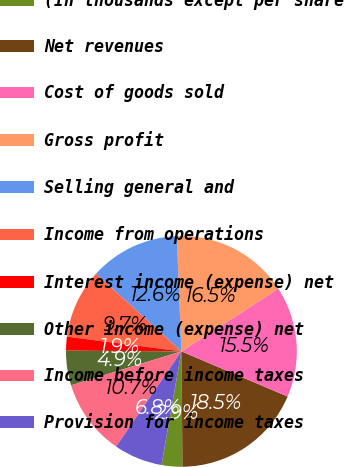Convert chart to OTSL. <chart><loc_0><loc_0><loc_500><loc_500><pie_chart><fcel>(In thousands except per share<fcel>Net revenues<fcel>Cost of goods sold<fcel>Gross profit<fcel>Selling general and<fcel>Income from operations<fcel>Interest income (expense) net<fcel>Other income (expense) net<fcel>Income before income taxes<fcel>Provision for income taxes<nl><fcel>2.91%<fcel>18.45%<fcel>15.53%<fcel>16.5%<fcel>12.62%<fcel>9.71%<fcel>1.94%<fcel>4.85%<fcel>10.68%<fcel>6.8%<nl></chart> 